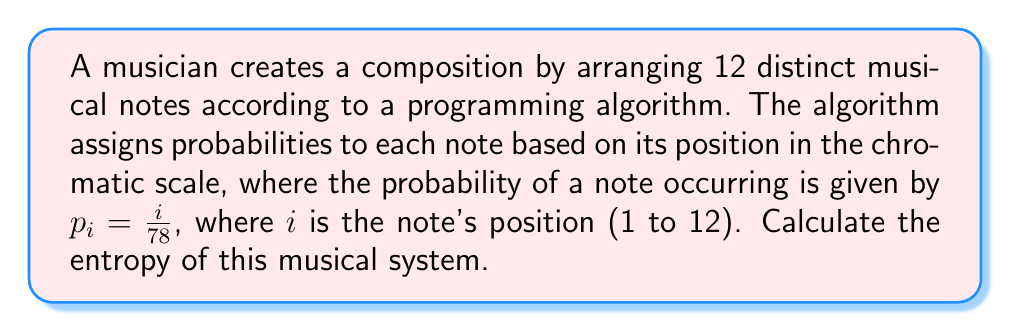Show me your answer to this math problem. To calculate the entropy of this musical system, we'll follow these steps:

1) The entropy of a discrete probability distribution is given by:
   $$S = -k_B \sum_{i=1}^{n} p_i \ln(p_i)$$
   where $k_B$ is Boltzmann's constant (which we'll take as 1 for simplicity) and $p_i$ is the probability of each state.

2) In this case, we have 12 notes with probabilities $p_i = \frac{i}{78}$ for $i = 1, 2, ..., 12$.

3) Let's substitute this into our entropy formula:
   $$S = -\sum_{i=1}^{12} \frac{i}{78} \ln(\frac{i}{78})$$

4) We can simplify this slightly:
   $$S = -\frac{1}{78} \sum_{i=1}^{12} i \ln(\frac{i}{78})$$

5) Now, we need to calculate this sum. Let's break it down:
   $$S = -\frac{1}{78} [1 \ln(\frac{1}{78}) + 2 \ln(\frac{2}{78}) + ... + 12 \ln(\frac{12}{78})]$$

6) Calculating this sum:
   $$S = -\frac{1}{78} [-4.3567 - 7.0279 - 8.7344 - 9.9183 - 10.7936 - 11.4484 - 11.9345 - 12.2865 - 12.5264 - 12.6721 - 12.7377 - 12.7347]$$

7) Summing up the values in the brackets:
   $$S = -\frac{1}{78} [-127.1712]$$

8) Simplifying:
   $$S = 1.6304$$

Therefore, the entropy of this musical system is approximately 1.6304.
Answer: 1.6304 